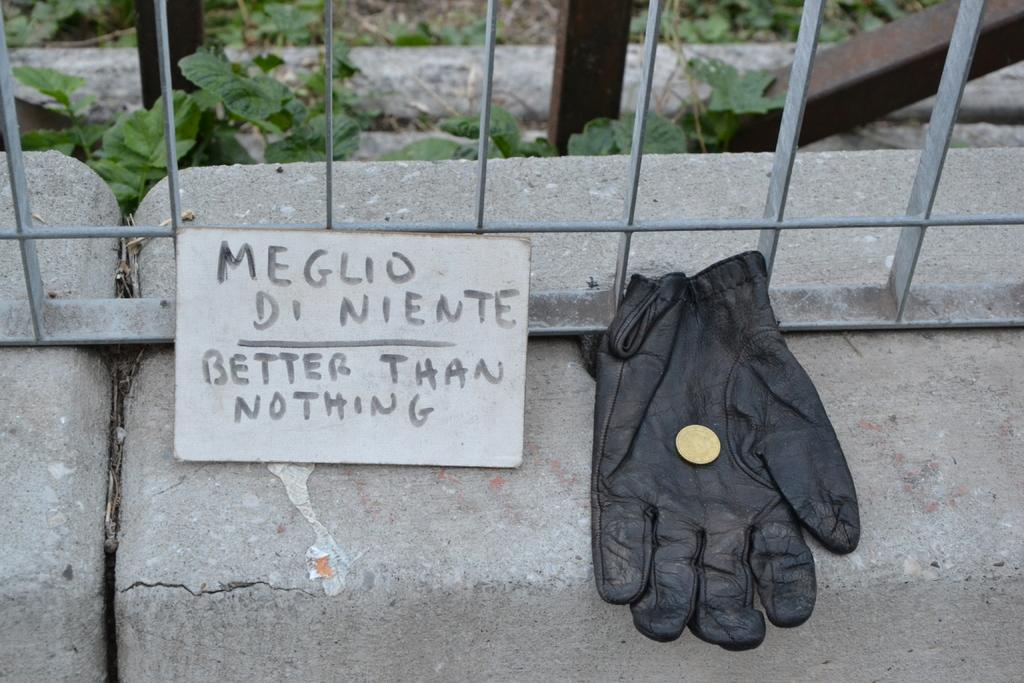What object is present on the glove in the image? A coin is on the glove in the image. What can be seen in the image besides the glove and coin? There is a name board, rods, stones, and leaves visible in the image. Can you describe the name board in the image? The name board is a flat surface with writing or symbols on it. What type of objects are the rods and stones in the image? The rods and stones are unspecified in the image, but they appear to be solid objects. What is visible in the background of the image? Leaves are visible in the background of the image. Can you tell me how many windows are visible in the image? There are no windows visible in the image. What color is the eye of the person in the image? There is no person or eye present in the image. 